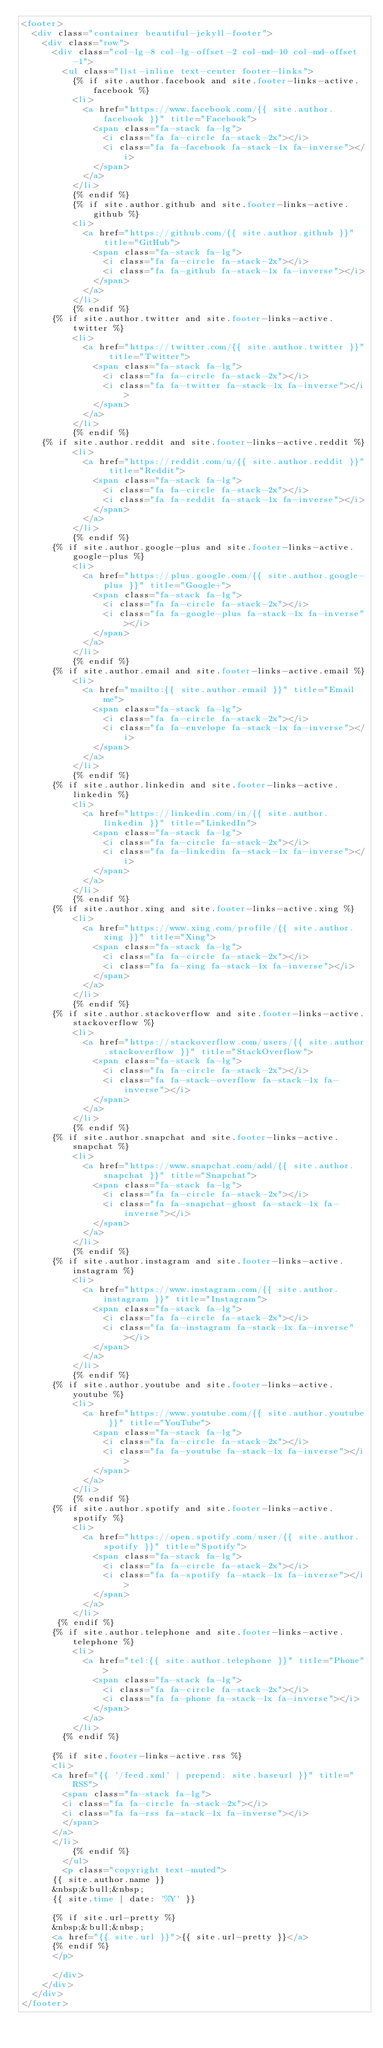<code> <loc_0><loc_0><loc_500><loc_500><_HTML_><footer>
  <div class="container beautiful-jekyll-footer">
    <div class="row">
      <div class="col-lg-8 col-lg-offset-2 col-md-10 col-md-offset-1">
        <ul class="list-inline text-center footer-links">
          {% if site.author.facebook and site.footer-links-active.facebook %}
          <li>
            <a href="https://www.facebook.com/{{ site.author.facebook }}" title="Facebook">
              <span class="fa-stack fa-lg">
                <i class="fa fa-circle fa-stack-2x"></i>
                <i class="fa fa-facebook fa-stack-1x fa-inverse"></i>
              </span>
            </a>
          </li>
          {% endif %}
          {% if site.author.github and site.footer-links-active.github %}
          <li>
            <a href="https://github.com/{{ site.author.github }}" title="GitHub">
              <span class="fa-stack fa-lg">
                <i class="fa fa-circle fa-stack-2x"></i>
                <i class="fa fa-github fa-stack-1x fa-inverse"></i>
              </span>
            </a>
          </li>
          {% endif %}
		  {% if site.author.twitter and site.footer-links-active.twitter %}
          <li>
            <a href="https://twitter.com/{{ site.author.twitter }}" title="Twitter">
              <span class="fa-stack fa-lg">
                <i class="fa fa-circle fa-stack-2x"></i>
                <i class="fa fa-twitter fa-stack-1x fa-inverse"></i>
              </span>
            </a>
          </li>
          {% endif %}
	  {% if site.author.reddit and site.footer-links-active.reddit %}
          <li>
            <a href="https://reddit.com/u/{{ site.author.reddit }}" title="Reddit">
              <span class="fa-stack fa-lg">
                <i class="fa fa-circle fa-stack-2x"></i>
                <i class="fa fa-reddit fa-stack-1x fa-inverse"></i>
              </span>
            </a>
          </li>
          {% endif %}
      {% if site.author.google-plus and site.footer-links-active.google-plus %}
          <li>
            <a href="https://plus.google.com/{{ site.author.google-plus }}" title="Google+">
              <span class="fa-stack fa-lg">
                <i class="fa fa-circle fa-stack-2x"></i>
                <i class="fa fa-google-plus fa-stack-1x fa-inverse"></i>
              </span>
            </a>
          </li>
          {% endif %}
		  {% if site.author.email and site.footer-links-active.email %}
          <li>
            <a href="mailto:{{ site.author.email }}" title="Email me">
              <span class="fa-stack fa-lg">
                <i class="fa fa-circle fa-stack-2x"></i>
                <i class="fa fa-envelope fa-stack-1x fa-inverse"></i>
              </span>
            </a>
          </li>
          {% endif %}
		  {% if site.author.linkedin and site.footer-links-active.linkedin %}
          <li>
            <a href="https://linkedin.com/in/{{ site.author.linkedin }}" title="LinkedIn">
              <span class="fa-stack fa-lg">
                <i class="fa fa-circle fa-stack-2x"></i>
                <i class="fa fa-linkedin fa-stack-1x fa-inverse"></i>
              </span>
            </a>
          </li>
          {% endif %}
		  {% if site.author.xing and site.footer-links-active.xing %}
          <li>
            <a href="https://www.xing.com/profile/{{ site.author.xing }}" title="Xing">
              <span class="fa-stack fa-lg">
                <i class="fa fa-circle fa-stack-2x"></i>
                <i class="fa fa-xing fa-stack-1x fa-inverse"></i>
              </span>
            </a>
          </li>
          {% endif %}
		  {% if site.author.stackoverflow and site.footer-links-active.stackoverflow %}
          <li>
            <a href="https://stackoverflow.com/users/{{ site.author.stackoverflow }}" title="StackOverflow">
              <span class="fa-stack fa-lg">
                <i class="fa fa-circle fa-stack-2x"></i>
                <i class="fa fa-stack-overflow fa-stack-1x fa-inverse"></i>
              </span>
            </a>
          </li>
          {% endif %}
      {% if site.author.snapchat and site.footer-links-active.snapchat %}
          <li>
            <a href="https://www.snapchat.com/add/{{ site.author.snapchat }}" title="Snapchat">
              <span class="fa-stack fa-lg">
                <i class="fa fa-circle fa-stack-2x"></i>
                <i class="fa fa-snapchat-ghost fa-stack-1x fa-inverse"></i>
              </span>
            </a>
          </li>
          {% endif %}
      {% if site.author.instagram and site.footer-links-active.instagram %}
          <li>
            <a href="https://www.instagram.com/{{ site.author.instagram }}" title="Instagram">
              <span class="fa-stack fa-lg">
                <i class="fa fa-circle fa-stack-2x"></i>
                <i class="fa fa-instagram fa-stack-1x fa-inverse"></i>
              </span>
            </a>
          </li>
          {% endif %}
      {% if site.author.youtube and site.footer-links-active.youtube %}
          <li>
            <a href="https://www.youtube.com/{{ site.author.youtube }}" title="YouTube">
              <span class="fa-stack fa-lg">
                <i class="fa fa-circle fa-stack-2x"></i>
                <i class="fa fa-youtube fa-stack-1x fa-inverse"></i>
              </span>
            </a>
          </li>
          {% endif %}
      {% if site.author.spotify and site.footer-links-active.spotify %}
          <li>
            <a href="https://open.spotify.com/user/{{ site.author.spotify }}" title="Spotify">
              <span class="fa-stack fa-lg">
                <i class="fa fa-circle fa-stack-2x"></i>
                <i class="fa fa-spotify fa-stack-1x fa-inverse"></i>
              </span>
            </a>
          </li>
       {% endif %}
      {% if site.author.telephone and site.footer-links-active.telephone %}
          <li>
            <a href="tel:{{ site.author.telephone }}" title="Phone">
              <span class="fa-stack fa-lg">
                <i class="fa fa-circle fa-stack-2x"></i>
                <i class="fa fa-phone fa-stack-1x fa-inverse"></i>
              </span>
            </a>
          </li>
        {% endif %}
        
		  {% if site.footer-links-active.rss %}
		  <li>
			<a href="{{ '/feed.xml' | prepend: site.baseurl }}" title="RSS">
			  <span class="fa-stack fa-lg">
				<i class="fa fa-circle fa-stack-2x"></i>
				<i class="fa fa-rss fa-stack-1x fa-inverse"></i>
			  </span>
			</a>
		  </li>
          {% endif %}
        </ul>
        <p class="copyright text-muted">
		  {{ site.author.name }}
		  &nbsp;&bull;&nbsp;
		  {{ site.time | date: '%Y' }}

		  {% if site.url-pretty %}
		  &nbsp;&bull;&nbsp;
		  <a href="{{ site.url }}">{{ site.url-pretty }}</a>
		  {% endif %}
	    </p>
	  
      </div>
    </div>
  </div>
</footer>
</code> 